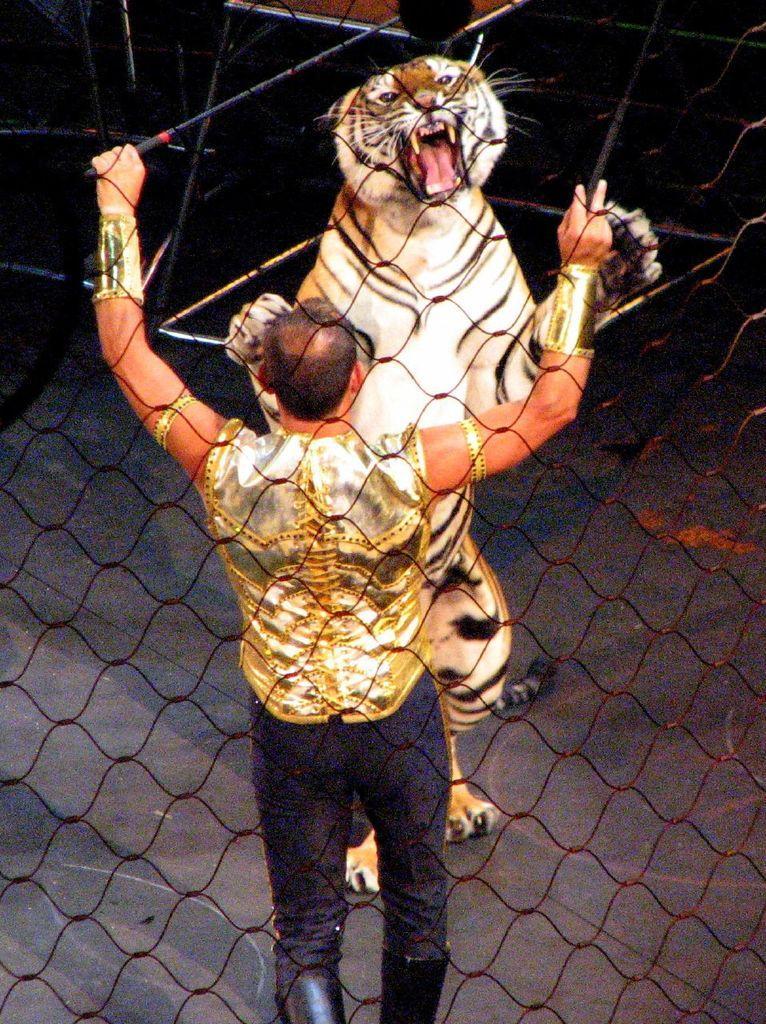In one or two sentences, can you explain what this image depicts? In this image, there is a black color fence, there is a man standing, there is a tiger standing and holding the fence. 